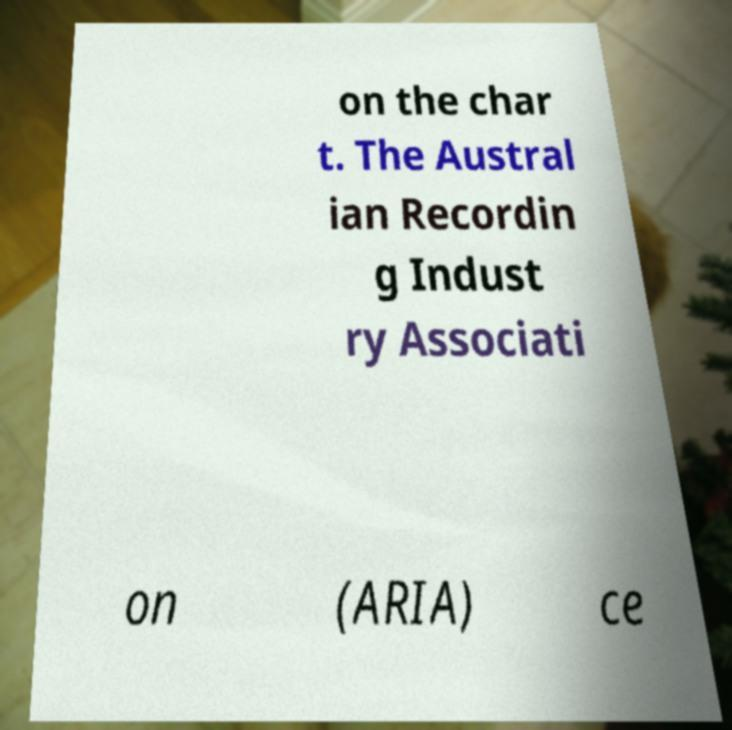What messages or text are displayed in this image? I need them in a readable, typed format. on the char t. The Austral ian Recordin g Indust ry Associati on (ARIA) ce 